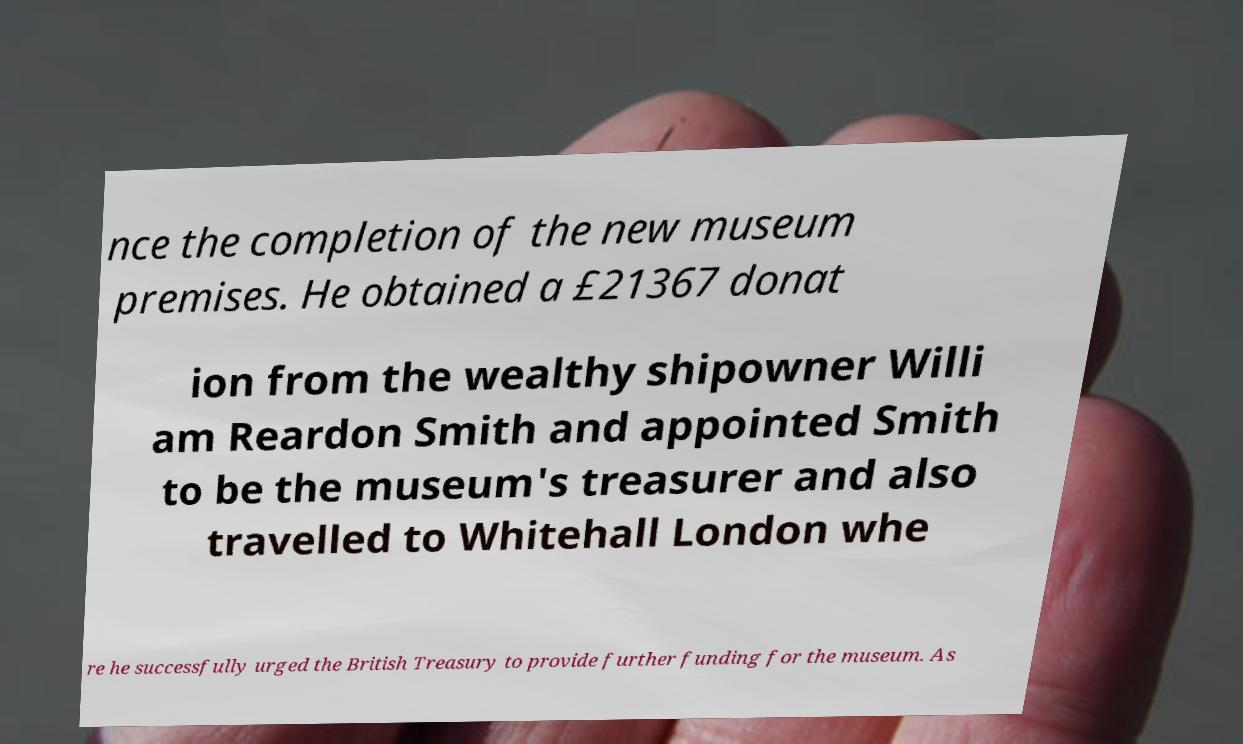Can you read and provide the text displayed in the image?This photo seems to have some interesting text. Can you extract and type it out for me? nce the completion of the new museum premises. He obtained a £21367 donat ion from the wealthy shipowner Willi am Reardon Smith and appointed Smith to be the museum's treasurer and also travelled to Whitehall London whe re he successfully urged the British Treasury to provide further funding for the museum. As 